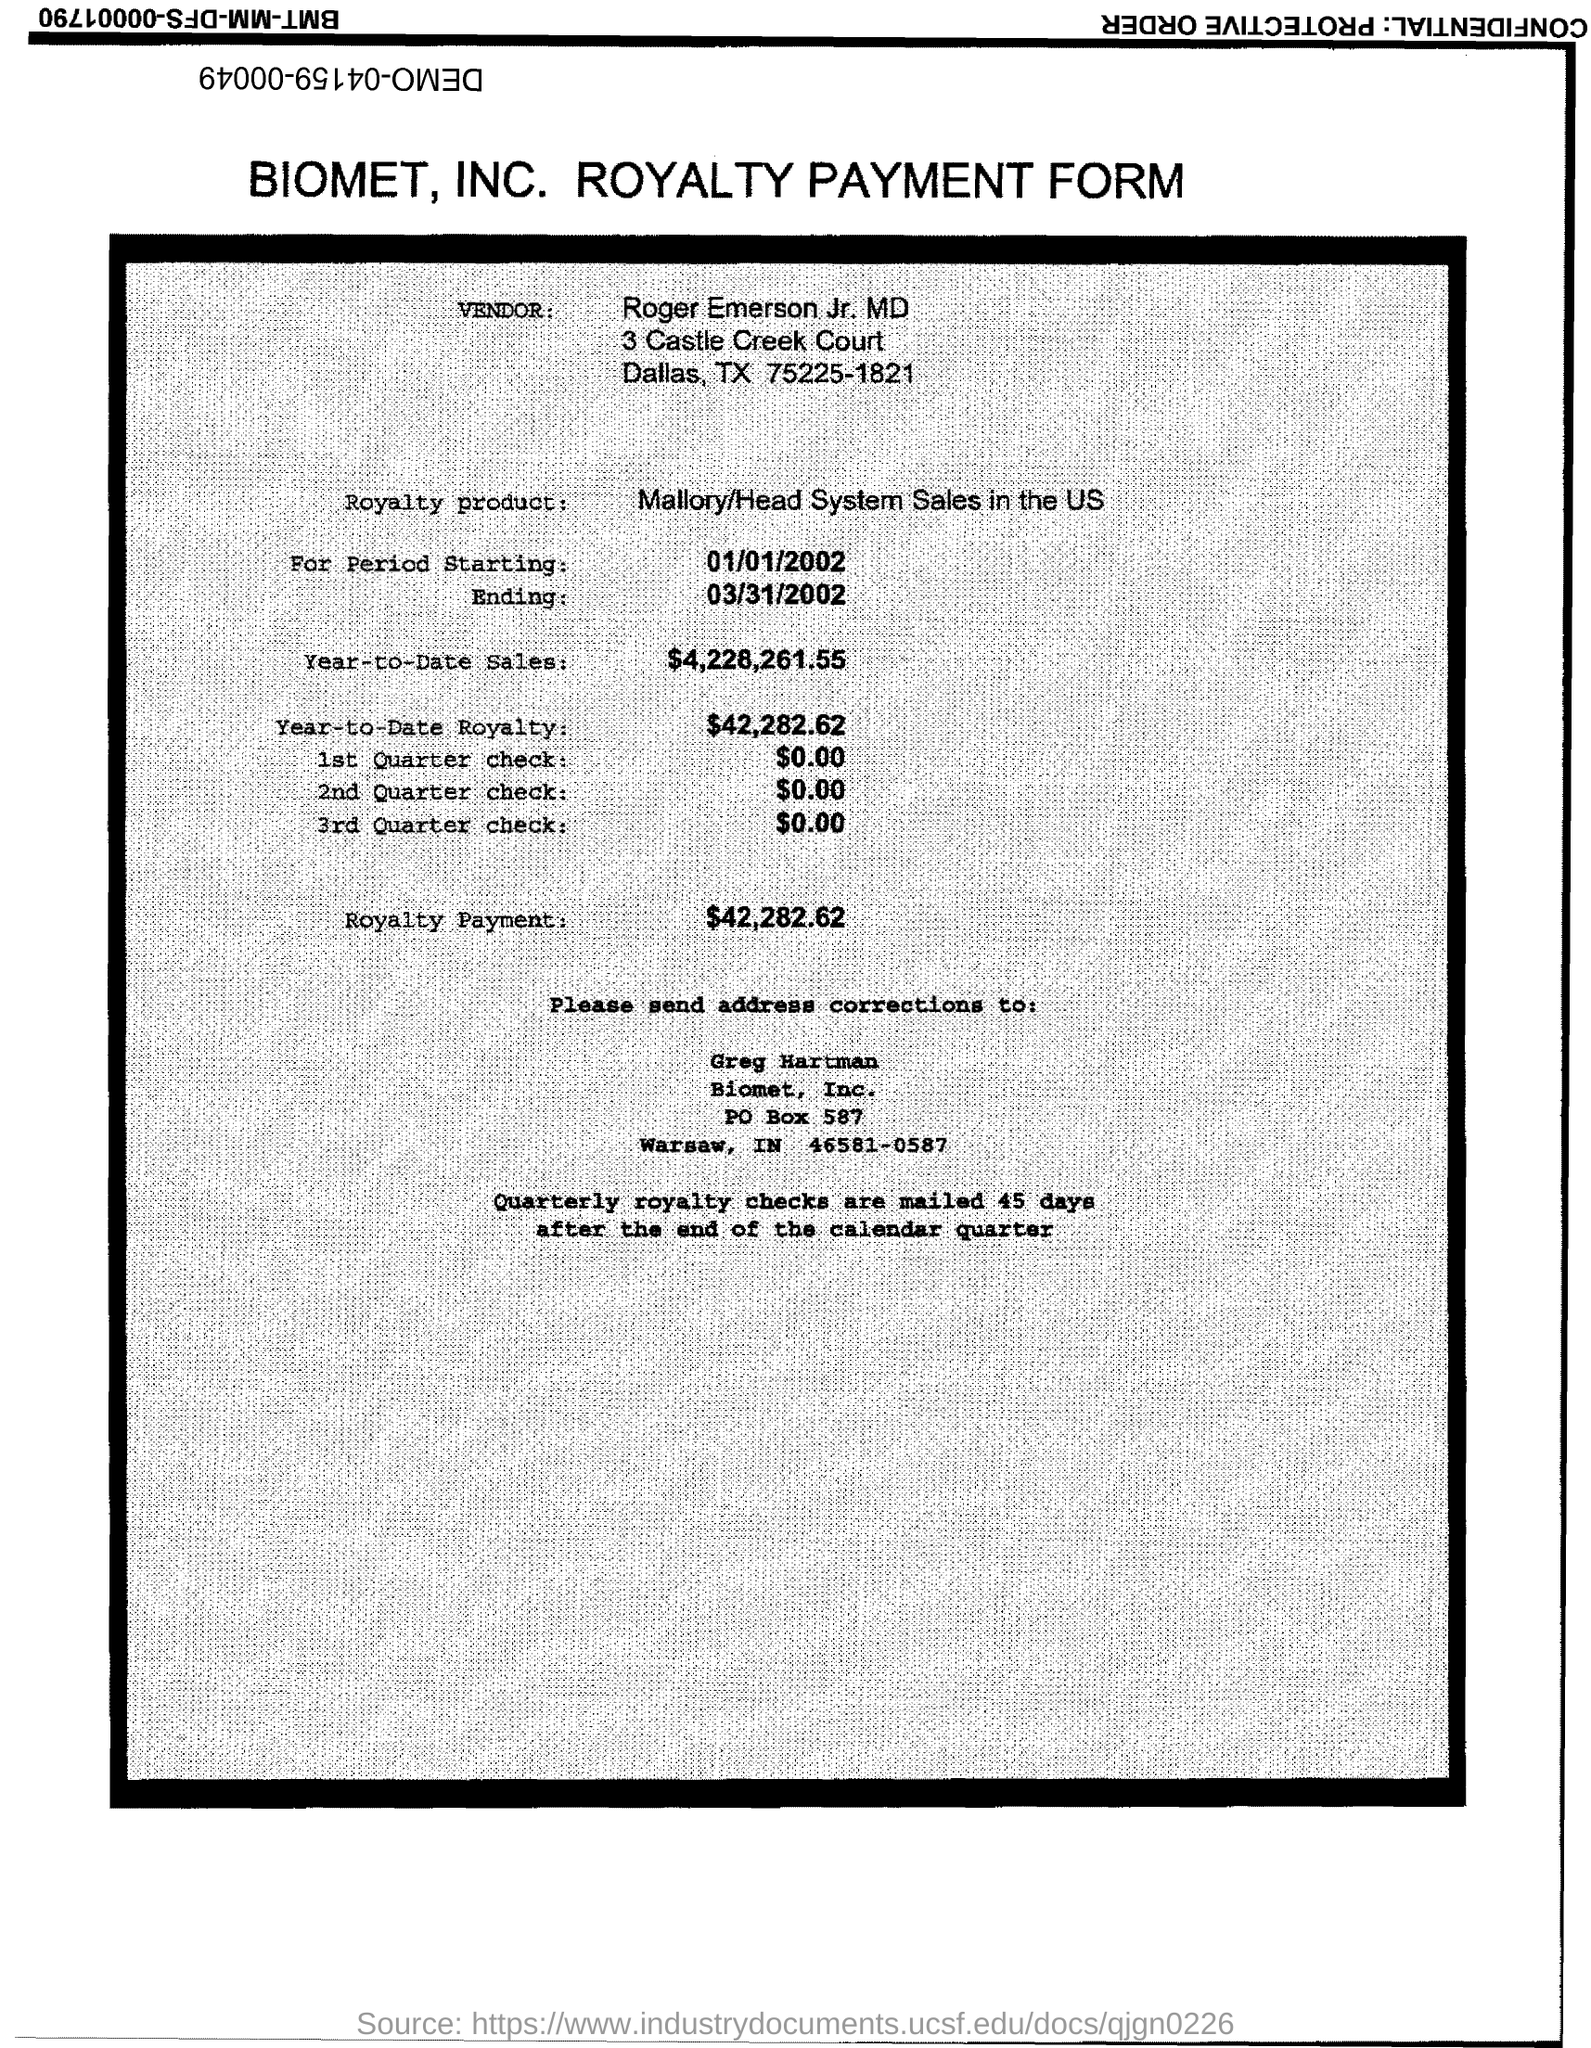Indicate a few pertinent items in this graphic. The start date of the royalty period is January 1, 2002. The amount of the 1st quarter check mentioned in the form is zero dollars and zero cents. The royalty product in the form is Mallory/Head System Sales in the US. The royalty payment for the product mentioned in the form is $42,282.62. The year-to-date royalty for the product is $42,282.62. 